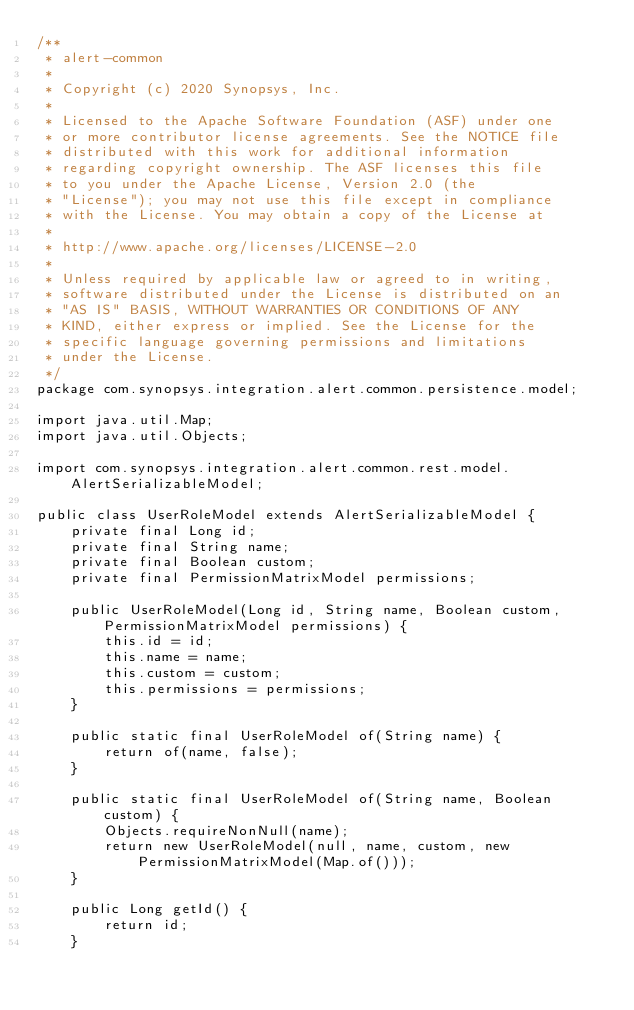<code> <loc_0><loc_0><loc_500><loc_500><_Java_>/**
 * alert-common
 *
 * Copyright (c) 2020 Synopsys, Inc.
 *
 * Licensed to the Apache Software Foundation (ASF) under one
 * or more contributor license agreements. See the NOTICE file
 * distributed with this work for additional information
 * regarding copyright ownership. The ASF licenses this file
 * to you under the Apache License, Version 2.0 (the
 * "License"); you may not use this file except in compliance
 * with the License. You may obtain a copy of the License at
 *
 * http://www.apache.org/licenses/LICENSE-2.0
 *
 * Unless required by applicable law or agreed to in writing,
 * software distributed under the License is distributed on an
 * "AS IS" BASIS, WITHOUT WARRANTIES OR CONDITIONS OF ANY
 * KIND, either express or implied. See the License for the
 * specific language governing permissions and limitations
 * under the License.
 */
package com.synopsys.integration.alert.common.persistence.model;

import java.util.Map;
import java.util.Objects;

import com.synopsys.integration.alert.common.rest.model.AlertSerializableModel;

public class UserRoleModel extends AlertSerializableModel {
    private final Long id;
    private final String name;
    private final Boolean custom;
    private final PermissionMatrixModel permissions;

    public UserRoleModel(Long id, String name, Boolean custom, PermissionMatrixModel permissions) {
        this.id = id;
        this.name = name;
        this.custom = custom;
        this.permissions = permissions;
    }

    public static final UserRoleModel of(String name) {
        return of(name, false);
    }

    public static final UserRoleModel of(String name, Boolean custom) {
        Objects.requireNonNull(name);
        return new UserRoleModel(null, name, custom, new PermissionMatrixModel(Map.of()));
    }

    public Long getId() {
        return id;
    }
</code> 